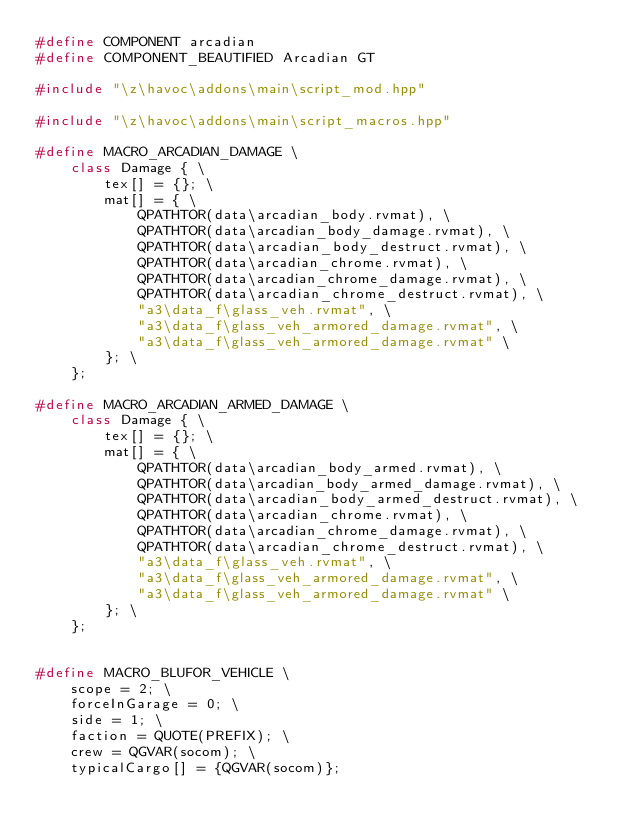<code> <loc_0><loc_0><loc_500><loc_500><_C++_>#define COMPONENT arcadian
#define COMPONENT_BEAUTIFIED Arcadian GT

#include "\z\havoc\addons\main\script_mod.hpp"

#include "\z\havoc\addons\main\script_macros.hpp"

#define MACRO_ARCADIAN_DAMAGE \
    class Damage { \
        tex[] = {}; \
        mat[] = { \
            QPATHTOR(data\arcadian_body.rvmat), \
            QPATHTOR(data\arcadian_body_damage.rvmat), \
            QPATHTOR(data\arcadian_body_destruct.rvmat), \
            QPATHTOR(data\arcadian_chrome.rvmat), \
            QPATHTOR(data\arcadian_chrome_damage.rvmat), \
            QPATHTOR(data\arcadian_chrome_destruct.rvmat), \
            "a3\data_f\glass_veh.rvmat", \
            "a3\data_f\glass_veh_armored_damage.rvmat", \
            "a3\data_f\glass_veh_armored_damage.rvmat" \
        }; \
    };

#define MACRO_ARCADIAN_ARMED_DAMAGE \
    class Damage { \
        tex[] = {}; \
        mat[] = { \
            QPATHTOR(data\arcadian_body_armed.rvmat), \
            QPATHTOR(data\arcadian_body_armed_damage.rvmat), \
            QPATHTOR(data\arcadian_body_armed_destruct.rvmat), \
            QPATHTOR(data\arcadian_chrome.rvmat), \
            QPATHTOR(data\arcadian_chrome_damage.rvmat), \
            QPATHTOR(data\arcadian_chrome_destruct.rvmat), \
            "a3\data_f\glass_veh.rvmat", \
            "a3\data_f\glass_veh_armored_damage.rvmat", \
            "a3\data_f\glass_veh_armored_damage.rvmat" \
        }; \
    };


#define MACRO_BLUFOR_VEHICLE \
    scope = 2; \
    forceInGarage = 0; \
    side = 1; \
    faction = QUOTE(PREFIX); \
    crew = QGVAR(socom); \
    typicalCargo[] = {QGVAR(socom)};
</code> 